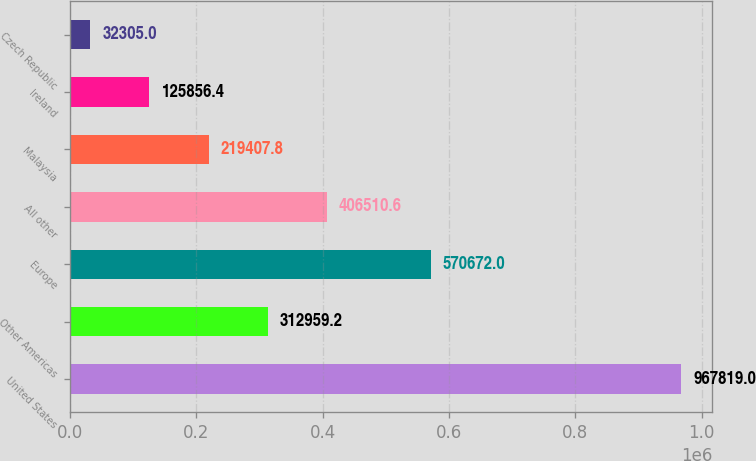Convert chart to OTSL. <chart><loc_0><loc_0><loc_500><loc_500><bar_chart><fcel>United States<fcel>Other Americas<fcel>Europe<fcel>All other<fcel>Malaysia<fcel>Ireland<fcel>Czech Republic<nl><fcel>967819<fcel>312959<fcel>570672<fcel>406511<fcel>219408<fcel>125856<fcel>32305<nl></chart> 